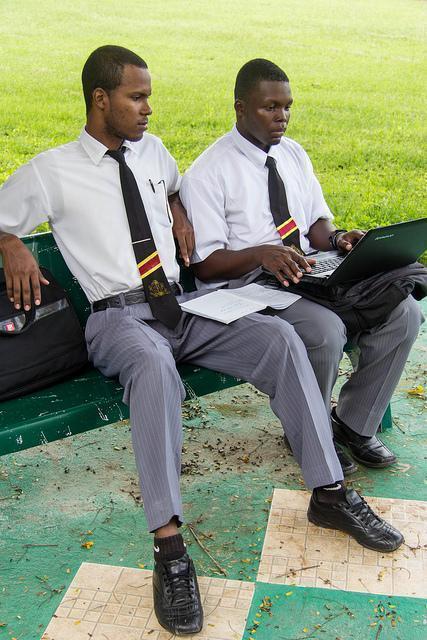What do the men's uniforms typically represent?
From the following four choices, select the correct answer to address the question.
Options: Sports, school, graduation, work. School. 